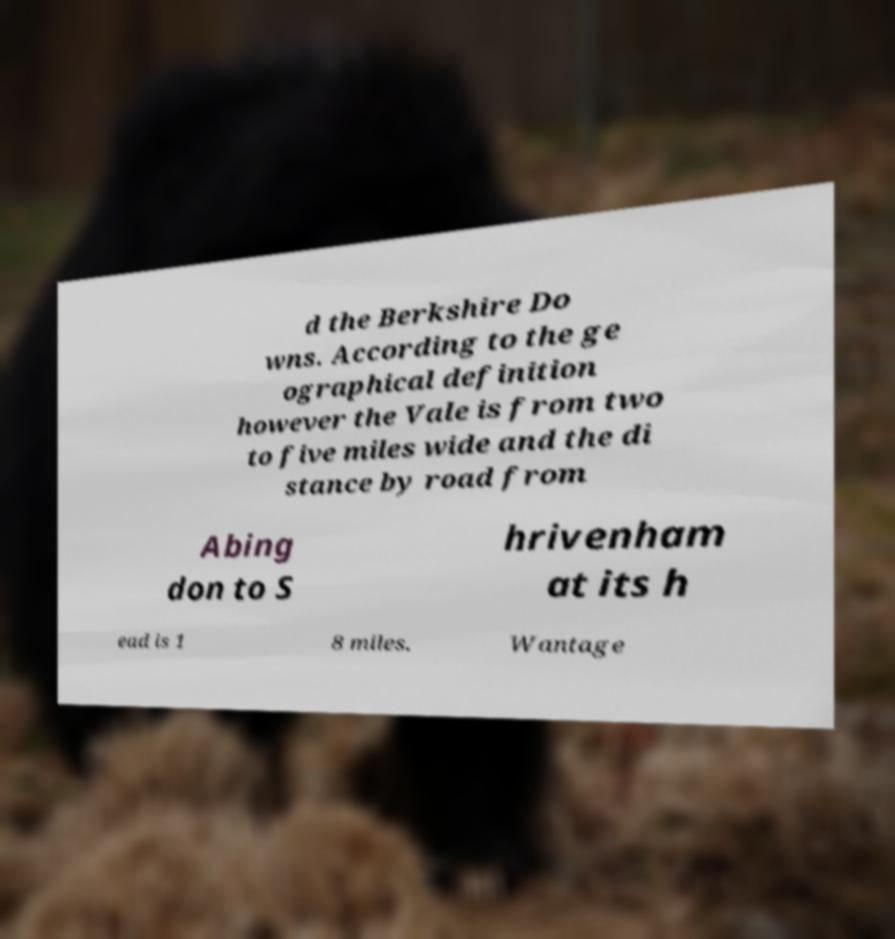I need the written content from this picture converted into text. Can you do that? d the Berkshire Do wns. According to the ge ographical definition however the Vale is from two to five miles wide and the di stance by road from Abing don to S hrivenham at its h ead is 1 8 miles. Wantage 